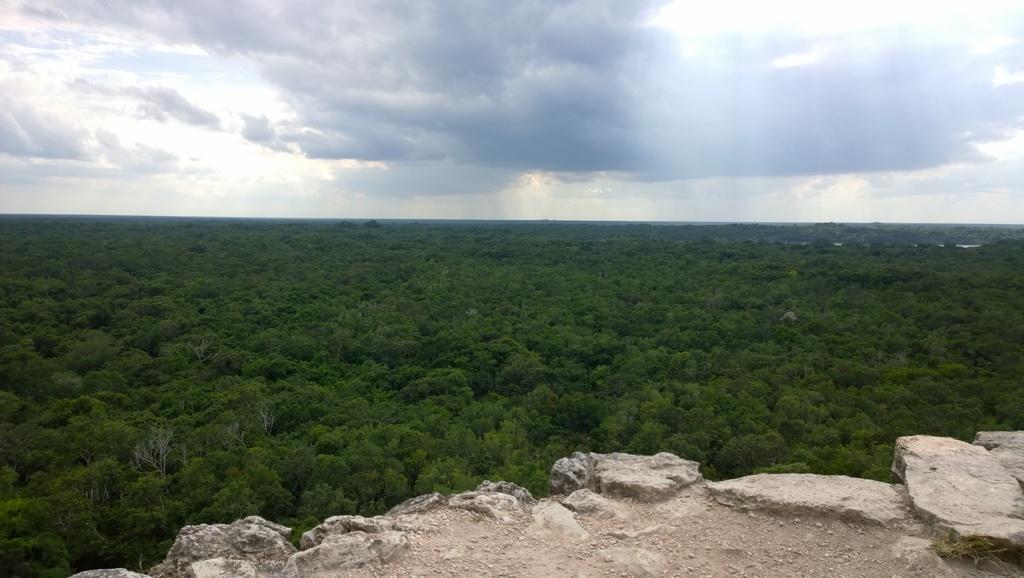How would you summarize this image in a sentence or two? As we can see in the image there are trees, rocks, sky and clouds. 